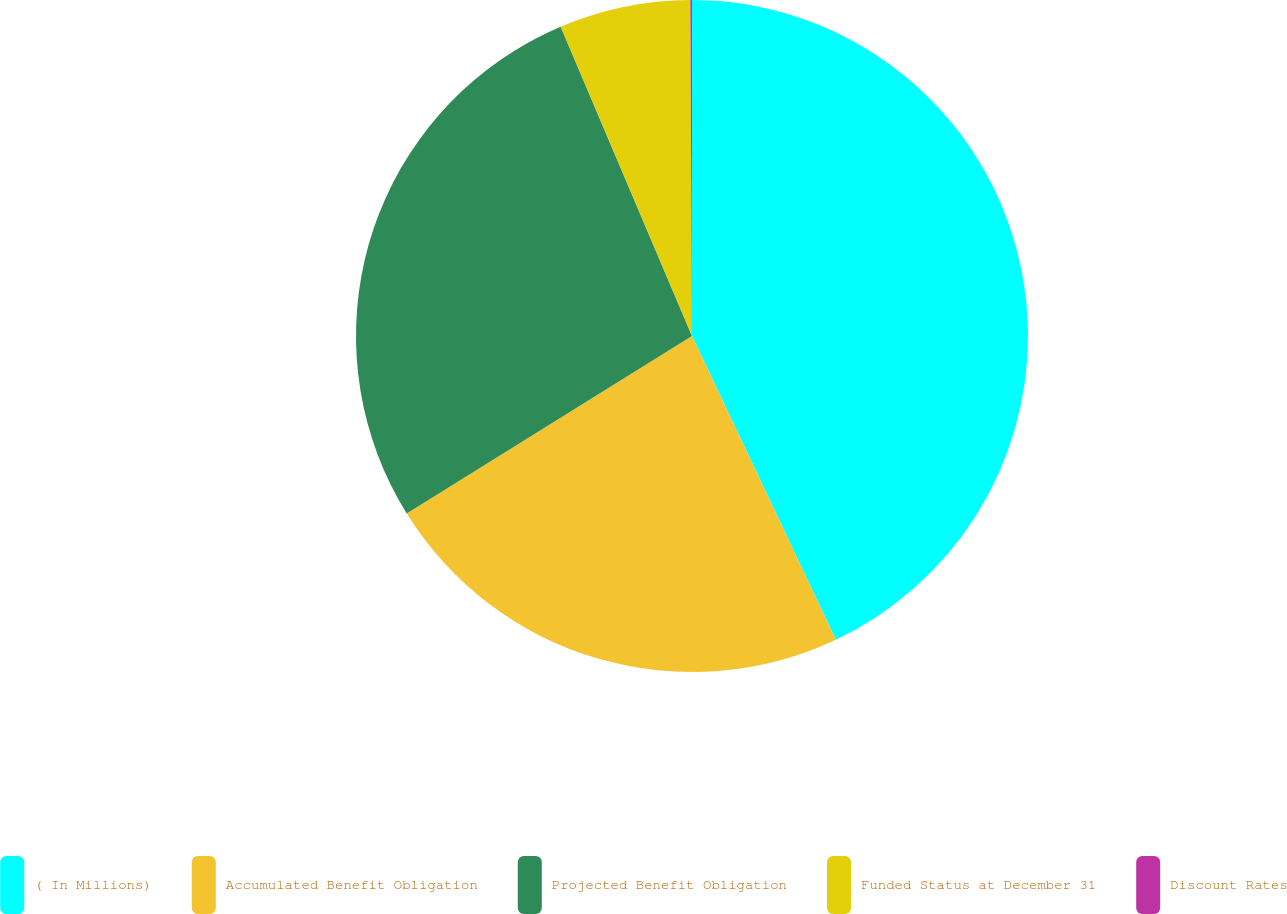Convert chart. <chart><loc_0><loc_0><loc_500><loc_500><pie_chart><fcel>( In Millions)<fcel>Accumulated Benefit Obligation<fcel>Projected Benefit Obligation<fcel>Funded Status at December 31<fcel>Discount Rates<nl><fcel>42.96%<fcel>23.18%<fcel>27.47%<fcel>6.31%<fcel>0.08%<nl></chart> 